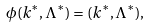Convert formula to latex. <formula><loc_0><loc_0><loc_500><loc_500>\phi ( k ^ { * } , \Lambda ^ { * } ) = ( k ^ { * } , \Lambda ^ { * } ) ,</formula> 